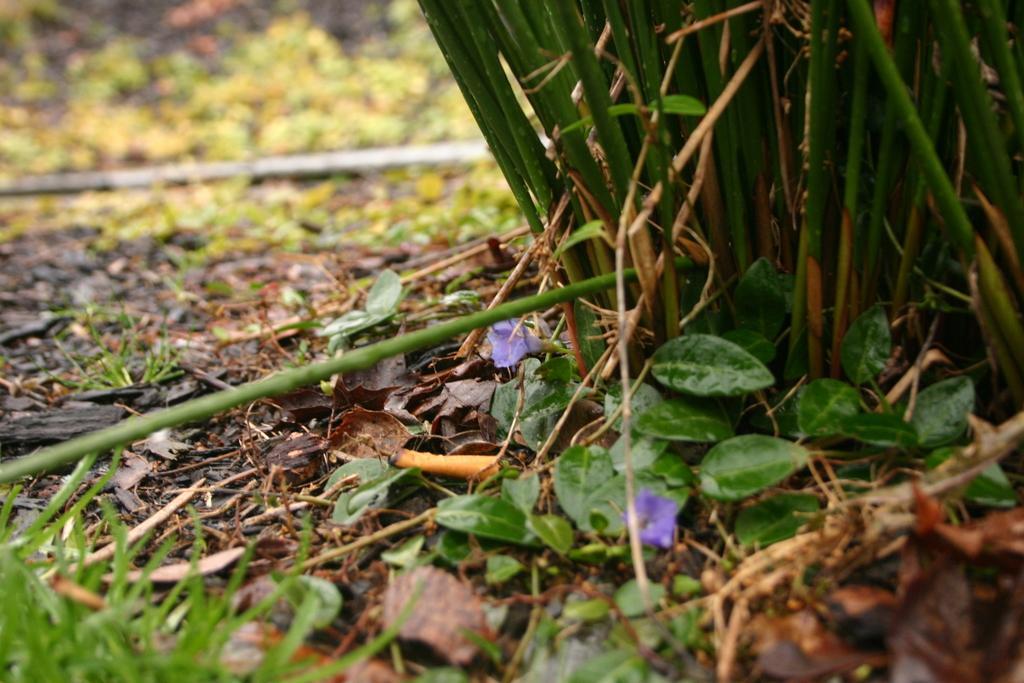Can you describe this image briefly? In this image we can see there is a grass on the surface and there are dry leaves, flowers and some wooden sticks. 